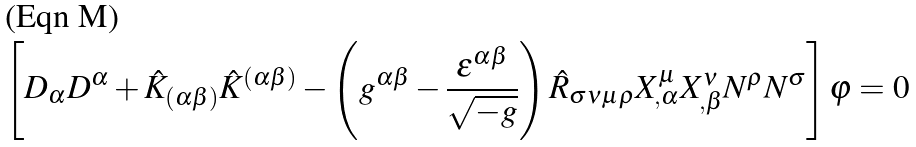<formula> <loc_0><loc_0><loc_500><loc_500>\left [ D _ { \alpha } D ^ { \alpha } + \hat { K } _ { ( \alpha \beta ) } \hat { K } ^ { ( \alpha \beta ) } - \left ( g ^ { \alpha \beta } - \frac { \epsilon ^ { \alpha \beta } } { \sqrt { - g } } \right ) \hat { R } _ { \sigma \nu \mu \rho } X ^ { \mu } _ { , \alpha } X ^ { \nu } _ { , \beta } N ^ { \rho } N ^ { \sigma } \right ] \varphi = 0</formula> 